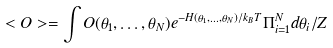Convert formula to latex. <formula><loc_0><loc_0><loc_500><loc_500>< O > = \int O ( \theta _ { 1 } , \dots , \theta _ { N } ) e ^ { - H ( \theta _ { 1 } , \dots , \theta _ { N } ) / k _ { B } T } \Pi _ { i = 1 } ^ { N } d \theta _ { i } / Z</formula> 